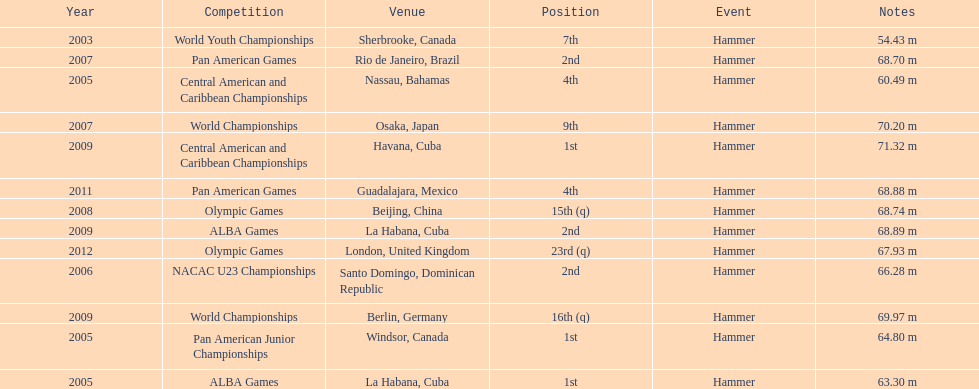In which olympic games did arasay thondike not finish in the top 20? 2012. 